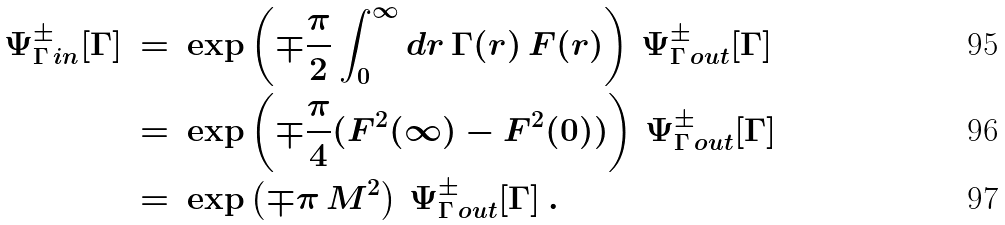Convert formula to latex. <formula><loc_0><loc_0><loc_500><loc_500>\Psi _ { \Gamma \, i n } ^ { \pm } [ \Gamma ] \, & = \, \exp \left ( \mp \frac { \pi } { 2 } \int _ { 0 } ^ { \infty } d r \, \Gamma ( r ) \, F ( r ) \right ) \, \Psi _ { \Gamma \, o u t } ^ { \pm } [ \Gamma ] \\ & = \, \exp \left ( \mp \frac { \pi } { 4 } ( F ^ { 2 } ( \infty ) - F ^ { 2 } ( 0 ) ) \right ) \, \Psi _ { \Gamma \, o u t } ^ { \pm } [ \Gamma ] \\ & = \, \exp \left ( \mp \pi \, M ^ { 2 } \right ) \, \Psi _ { \Gamma \, o u t } ^ { \pm } [ \Gamma ] \, .</formula> 